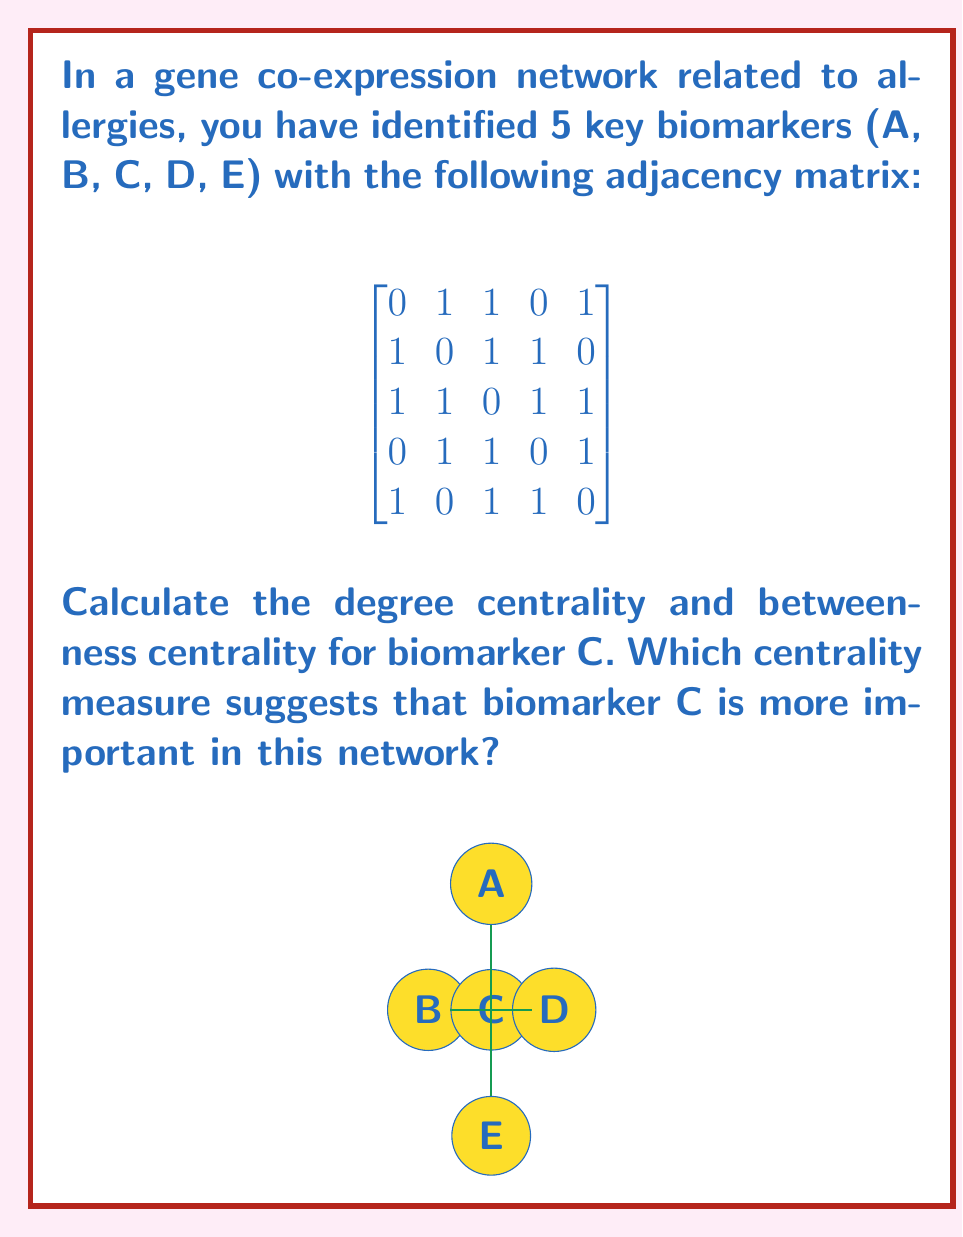Solve this math problem. To solve this problem, we need to calculate both the degree centrality and betweenness centrality for biomarker C.

1. Degree Centrality:
   The degree centrality is the number of direct connections a node has.
   From the adjacency matrix, we can see that biomarker C is connected to all other biomarkers.
   Degree of C = 4
   Normalized degree centrality = $\frac{4}{5-1} = 1$

2. Betweenness Centrality:
   Betweenness centrality measures how often a node appears on the shortest paths between other nodes.
   
   For a network with 5 nodes, there are $\binom{5}{2} = 10$ possible pairs.
   
   Let's count the shortest paths that pass through C:
   A-C-B, A-C-D, B-C-E, D-C-E
   
   There are 4 shortest paths that pass through C out of 10 total pairs.
   
   Betweenness centrality of C = $\frac{4}{10} = 0.4$

3. Comparison:
   Degree centrality of C: 1 (maximum possible value)
   Betweenness centrality of C: 0.4

   The degree centrality suggests that biomarker C is more important in this network, as it has reached the maximum possible value of 1, indicating that it is directly connected to all other nodes in the network.
Answer: Degree centrality suggests biomarker C is more important (Degree centrality = 1, Betweenness centrality = 0.4). 